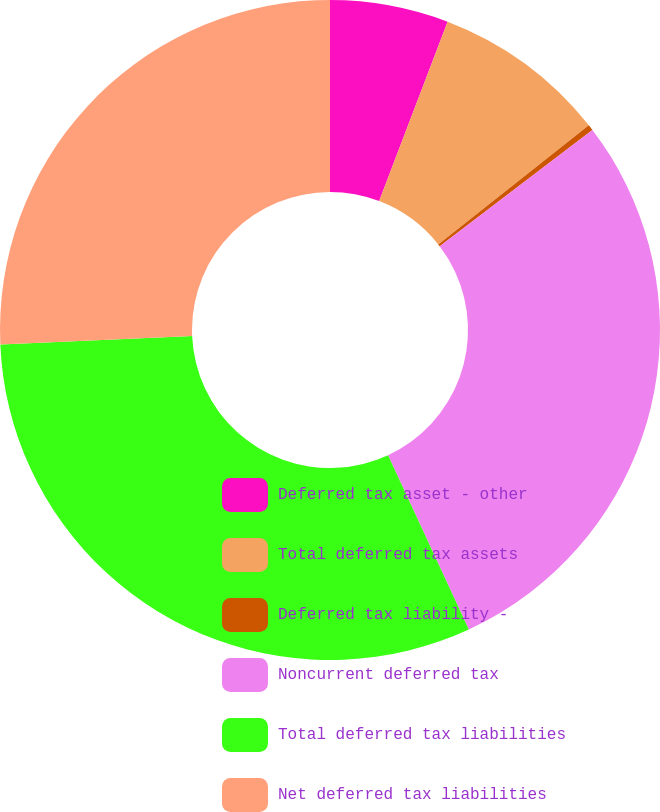Convert chart. <chart><loc_0><loc_0><loc_500><loc_500><pie_chart><fcel>Deferred tax asset - other<fcel>Total deferred tax assets<fcel>Deferred tax liability -<fcel>Noncurrent deferred tax<fcel>Total deferred tax liabilities<fcel>Net deferred tax liabilities<nl><fcel>5.8%<fcel>8.55%<fcel>0.28%<fcel>28.46%<fcel>31.21%<fcel>25.7%<nl></chart> 